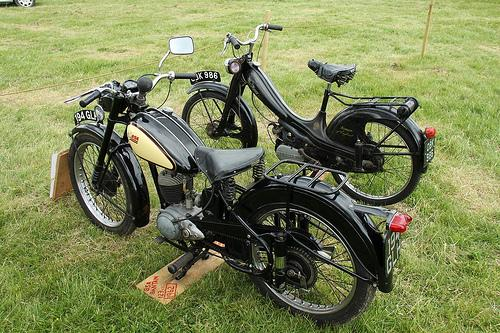What is the landscape setting in the image? The landscape has green and thick grass. Identify the primary object in the image and its color. The primary object in the image is a black motorcycle. Are there any small structures or barriers around the motorcycles? There is a small wood post and a rope around the motorcycles. Describe the details visible on a small part of the motorcycle, such as a license plate. The license plate is black and white with letters and numbers. What elements in the image suggest that the motorcycles are old? The overall description and the phrase "two old black motorcycles" suggest that they are old. Elaborate on the wheels of the motorcycles depicted in the image. The motorcycles have black wheels with black spokes. How would you describe the location of the bicycles in the image? The bicycles are parked on the grass. What is one distinguishing feature of the motorcycle? The motorcycle has a black and tan gas tank. What is the primary color of the motorcycle and what does it appear to be doing? The motorcycle is black and appears to be parked on the grass. Mention the position of the big cardboard in relation to the motorcycle. The big cardboard is underneath the motorcycle. 